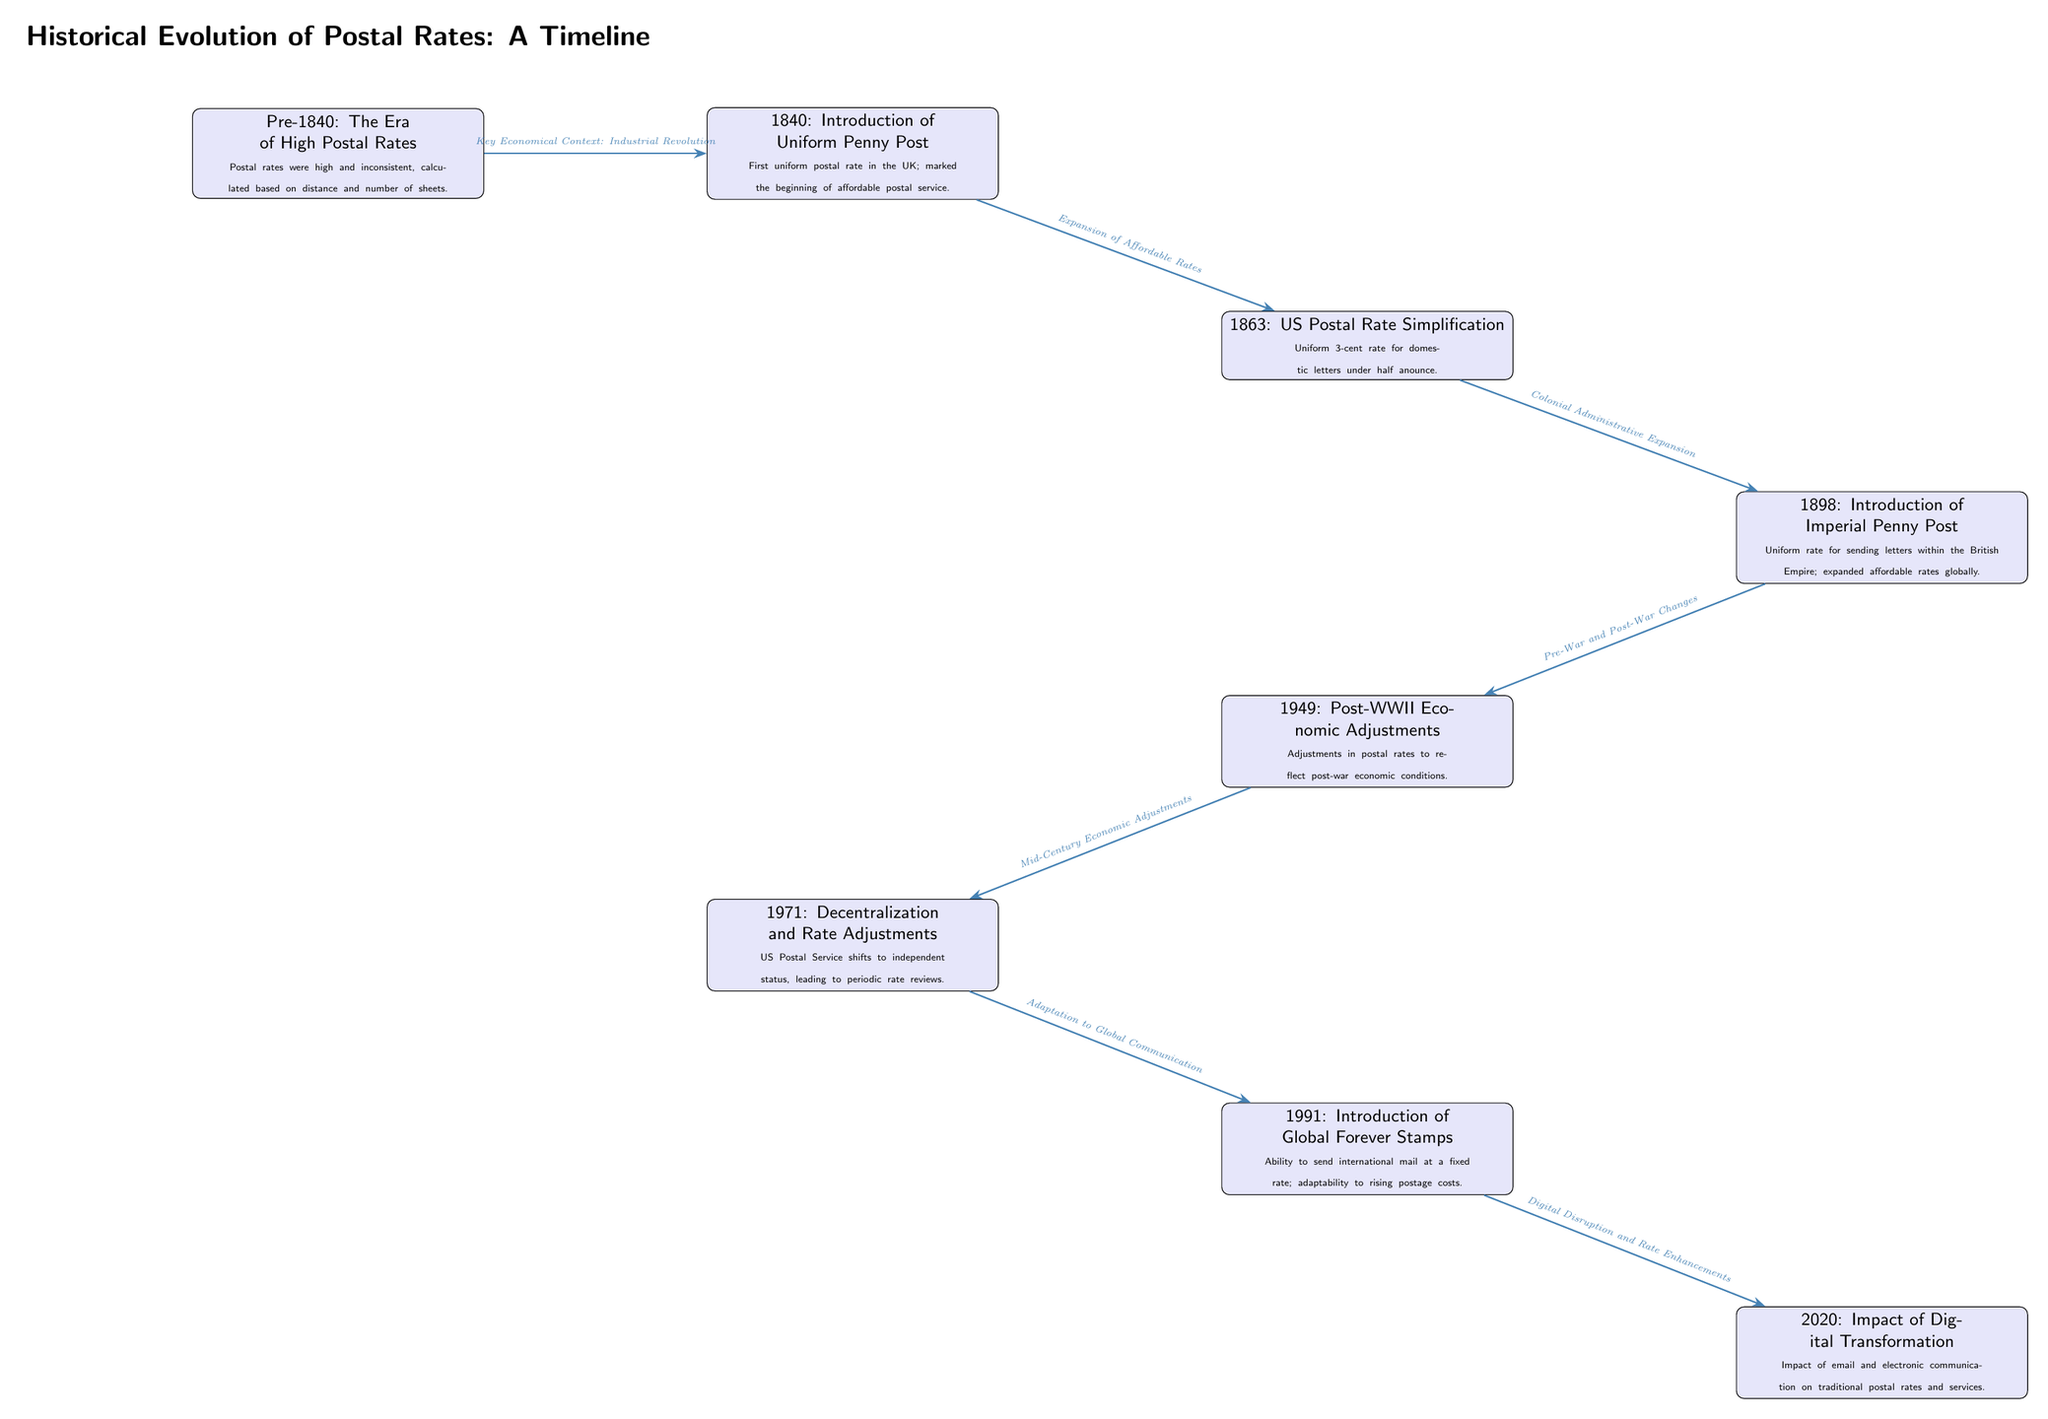What is the first event listed in the timeline? The first event in the timeline is "Pre-1840: The Era of High Postal Rates," which is located at the far left of the diagram.
Answer: Pre-1840: The Era of High Postal Rates What year did the UK introduce the Uniform Penny Post? According to the timeline in the diagram, the Uniform Penny Post was introduced in 1840, as noted in the second node from the left.
Answer: 1840 How many events are shown in the diagram? By counting the nodes in the timeline, there are a total of 8 events depicted.
Answer: 8 What is the key economical context linked to the event in 1840? The arrow pointing from the event in 1840 to the one in 1863 is annotated with "Key Economical Context: Industrial Revolution," which provides the context for that timeframe.
Answer: Industrial Revolution What relationship exists between the 1971 and 1991 events? The arrow from the 1971 event to the 1991 event is labeled "Adaptation to Global Communication," indicating a direct relationship between the two discussing changes in postal services.
Answer: Adaptation to Global Communication Which event marks the introduction of Global Forever Stamps? The diagram identifies the event "1991: Introduction of Global Forever Stamps" as the one marking this introduction, located near the bottom right of the timeline.
Answer: 1991: Introduction of Global Forever Stamps What economic adjustment took place in 1949? The event labeled "1949: Post-WWII Economic Adjustments" indicates that alterations in postal rates were made in response to post-war economic conditions.
Answer: Post-WWII Economic Adjustments What significant change occurred in 2020 relating to postal rates? The diagram notes "2020: Impact of Digital Transformation," which addresses how digital communication affected traditional postal rates and services during that year.
Answer: Impact of Digital Transformation What does the arrow from 1991 to 2020 signify in terms of communication? The arrow between these two events is annotated with "Digital Disruption and Rate Enhancements," indicating the influence of digital advancements on postal services and rates.
Answer: Digital Disruption and Rate Enhancements 